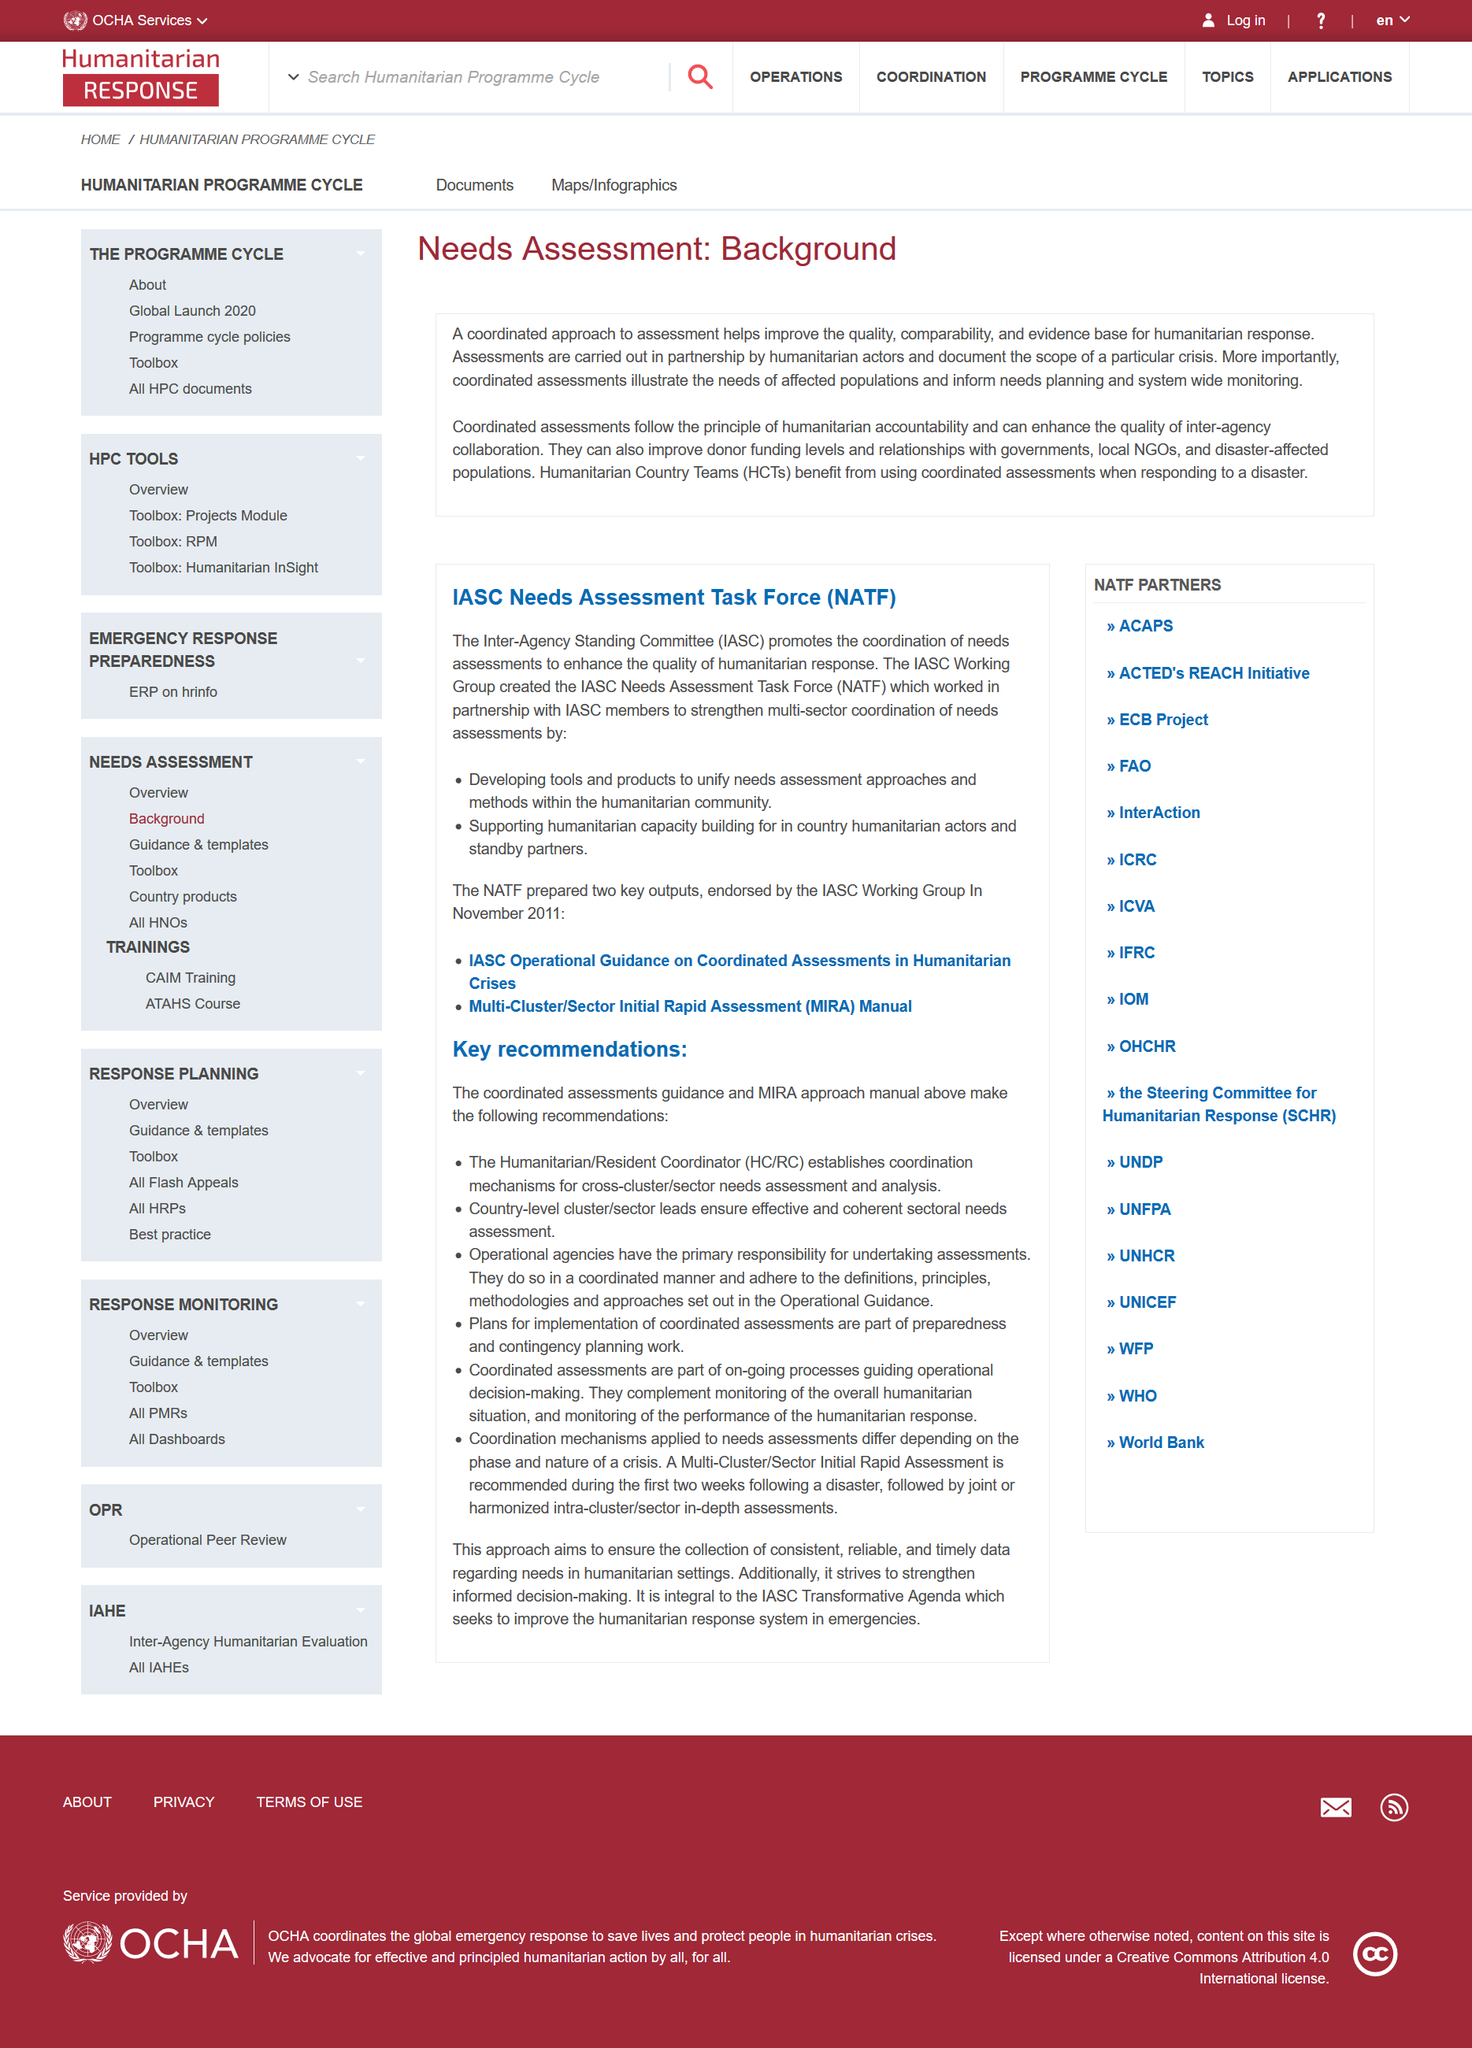Specify some key components in this picture. IASC stands for Inter-Agency Standing Committee, which is a group of various organizations that work together to address and provide assistance in the aftermath of a humanitarian crisis. Coordinated assessment is essential for improving the quality, comparability, and evidence base of humanitarian response. The NATF provided support for humanitarian capacity building for in-country humanitarian actors, demonstrating its commitment to improving humanitarian assistance. Needs Assessment Task Force is the acronym for NATF. This document provides the background of a needs assessment. 